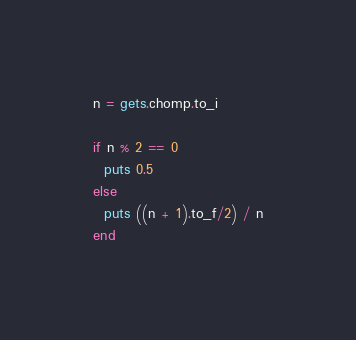Convert code to text. <code><loc_0><loc_0><loc_500><loc_500><_Ruby_>n = gets.chomp.to_i

if n % 2 == 0
  puts 0.5
else
  puts ((n + 1).to_f/2) / n
end
</code> 